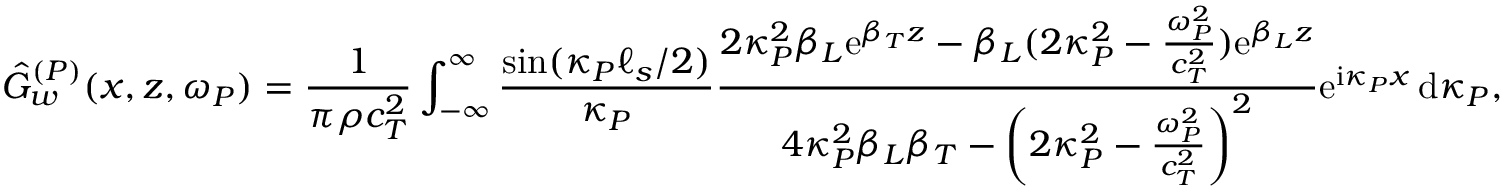Convert formula to latex. <formula><loc_0><loc_0><loc_500><loc_500>\hat { G } _ { w } ^ { ( P ) } ( x , z , \omega _ { P } ) = \frac { 1 } { \pi \rho c _ { T } ^ { 2 } } \int _ { - \infty } ^ { \infty } \frac { \sin ( \kappa _ { P } \ell _ { s } / 2 ) } { \kappa _ { P } } \frac { 2 \kappa _ { P } ^ { 2 } \beta _ { L } e ^ { \beta _ { T } z } - \beta _ { L } ( 2 \kappa _ { P } ^ { 2 } - \frac { \omega _ { P } ^ { 2 } } { c _ { T } ^ { 2 } } ) e ^ { \beta _ { L } z } } { 4 \kappa _ { P } ^ { 2 } \beta _ { L } \beta _ { T } - \left ( 2 \kappa _ { P } ^ { 2 } - \frac { \omega _ { P } ^ { 2 } } { c _ { T } ^ { 2 } } \right ) ^ { 2 } } e ^ { i \kappa _ { P } x } \, d \kappa _ { P } ,</formula> 